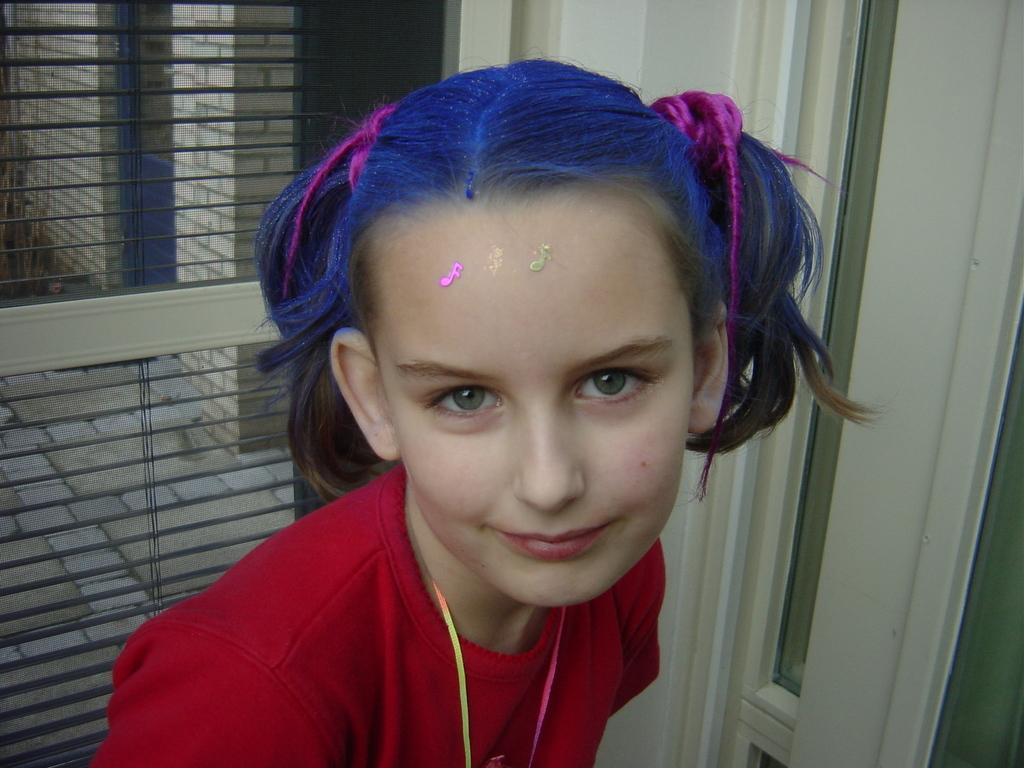Who is the main subject in the image? There is a girl in the image. What is a unique feature of the girl's appearance? The girl has colored hair. What can be seen in the background of the image? There is a window in the background of the image. What architectural feature is present on the right side of the image? There is a door with a glass on the right side of the image. What type of mist can be seen coming from the girl's hair in the image? There is no mist present in the image; the girl has colored hair. How is the distribution of office supplies in the image? There is no mention of office supplies or an office setting in the image. 